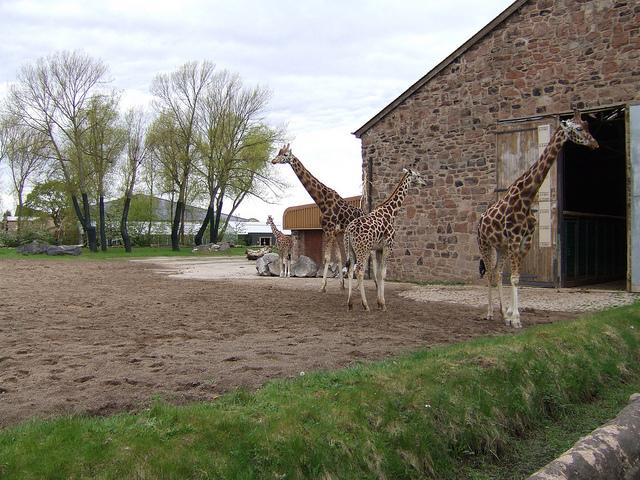What type of animal is shown? Please explain your reasoning. wild. The animal is wild. 